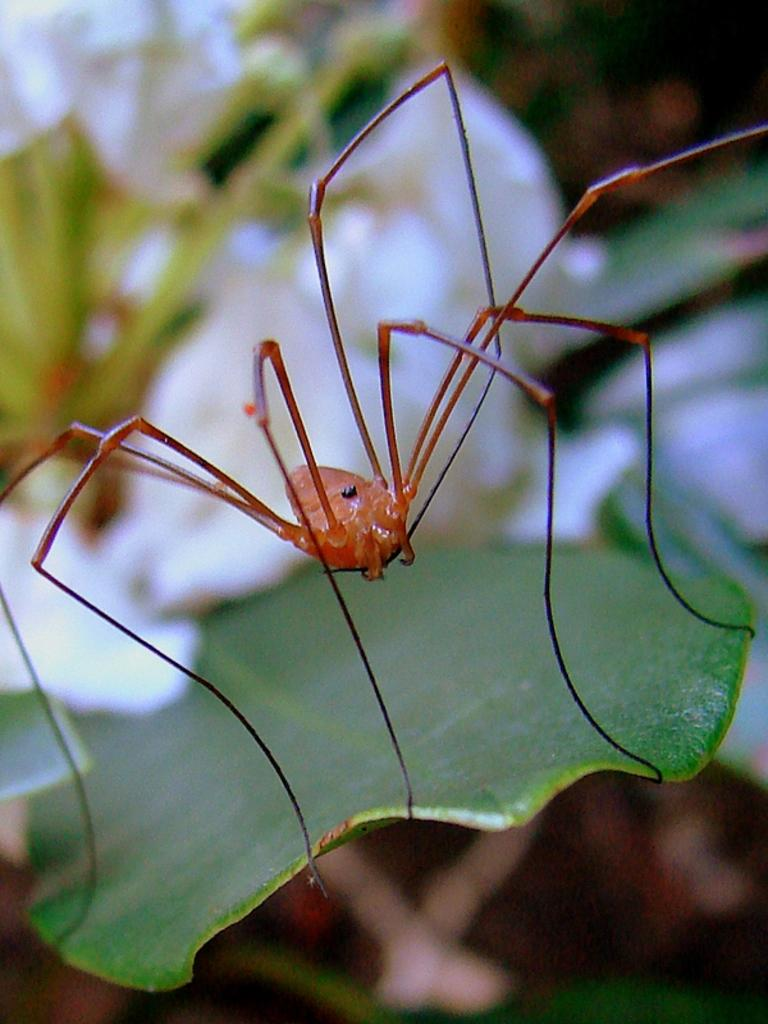What is the main subject of the image? The main subject of the image is a spider. Where is the spider located in the image? The spider is on a leaf. Can you describe the background of the image? The background of the image is blurry. What type of porter can be seen carrying luggage in the image? There is no porter carrying luggage present in the image. What is the visibility like in the image due to the rail? There is no rail present in the image, and therefore no impact on visibility. What type of fog can be seen surrounding the spider in the image? There is no fog present in the image; the background is simply blurry. 